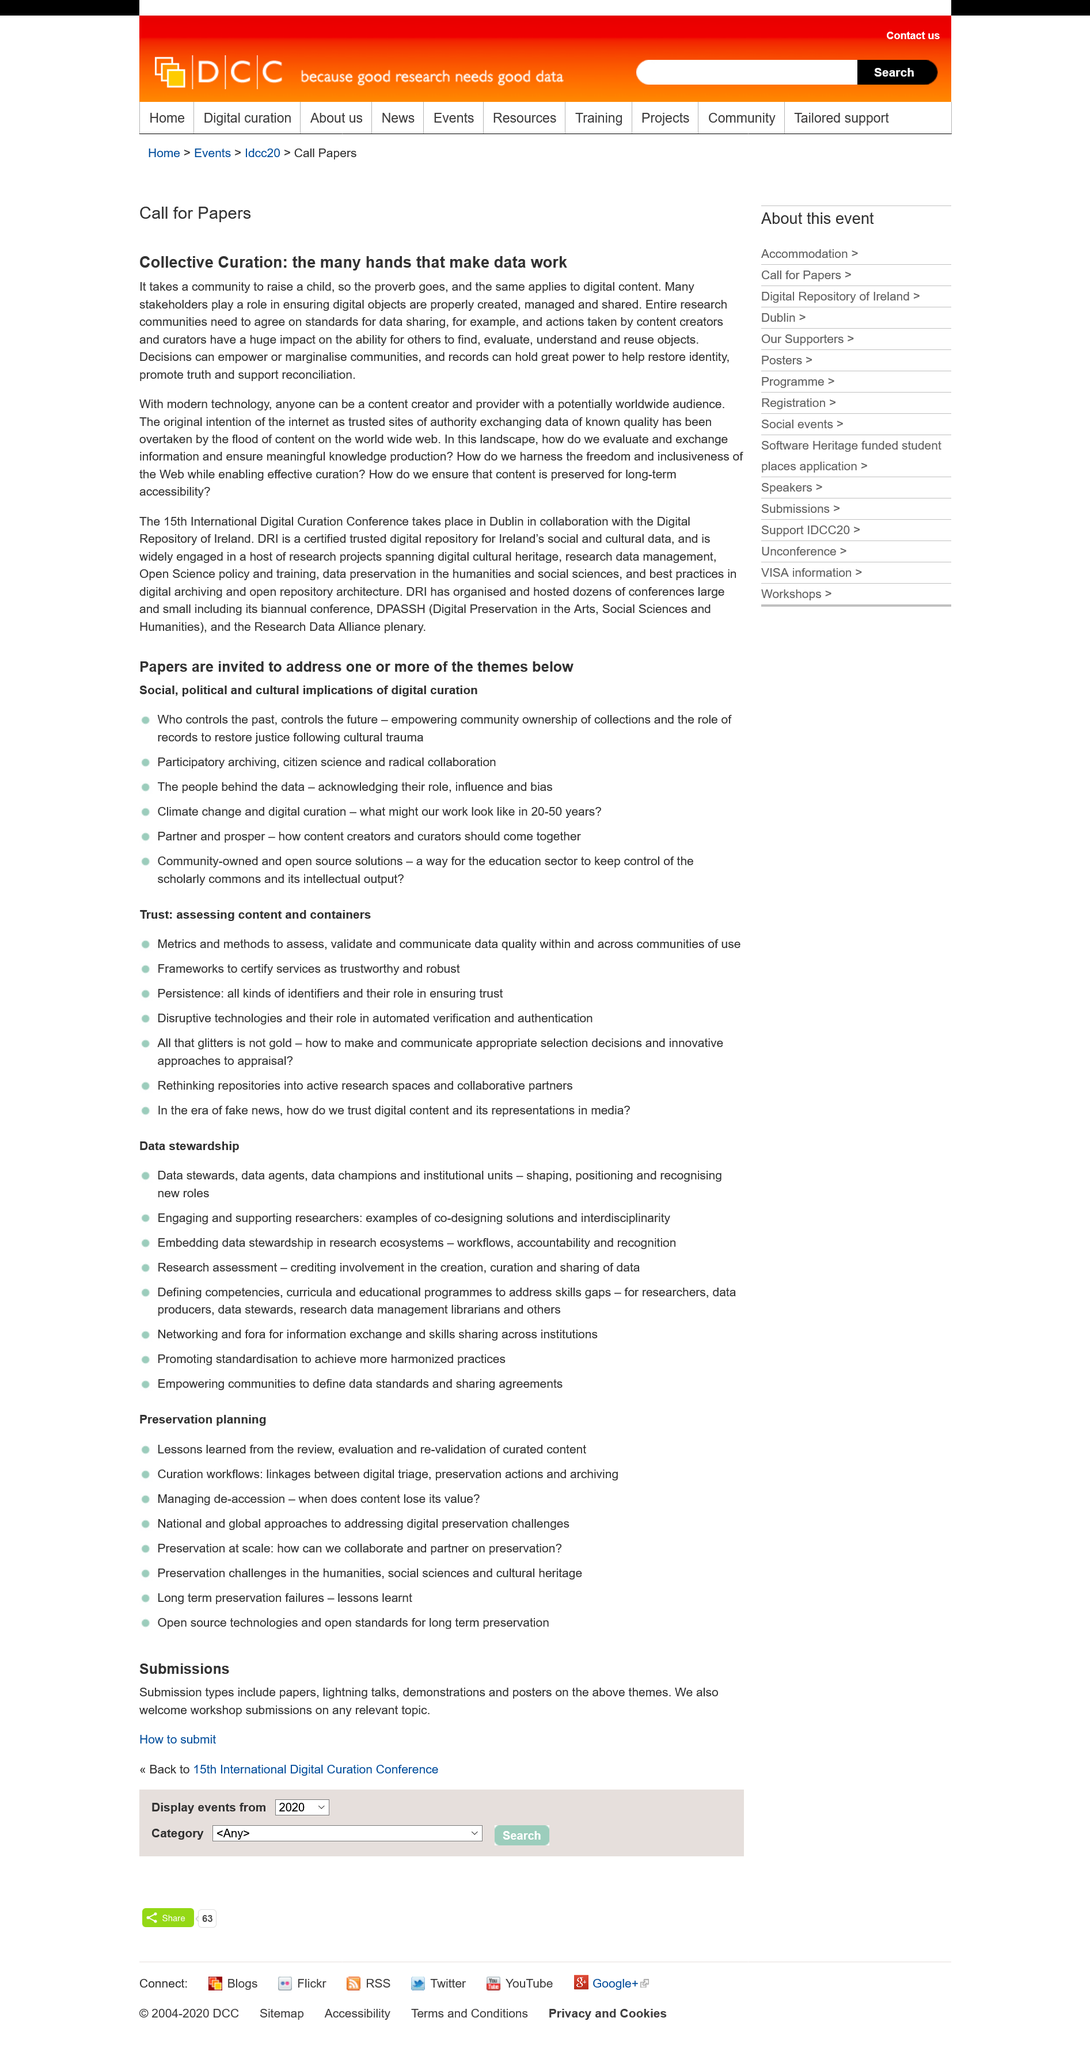Identify some key points in this picture. Stakeholders play a critical role in collective curation, ensuring that digital objects are properly created, managed, and shared. In today's digital age, anyone with a passion and the necessary tools can become a content creator and reach a potentially global audience. The original intention of the internet was to establish trusted sources of authority for the purpose of exchanging data of established quality. 